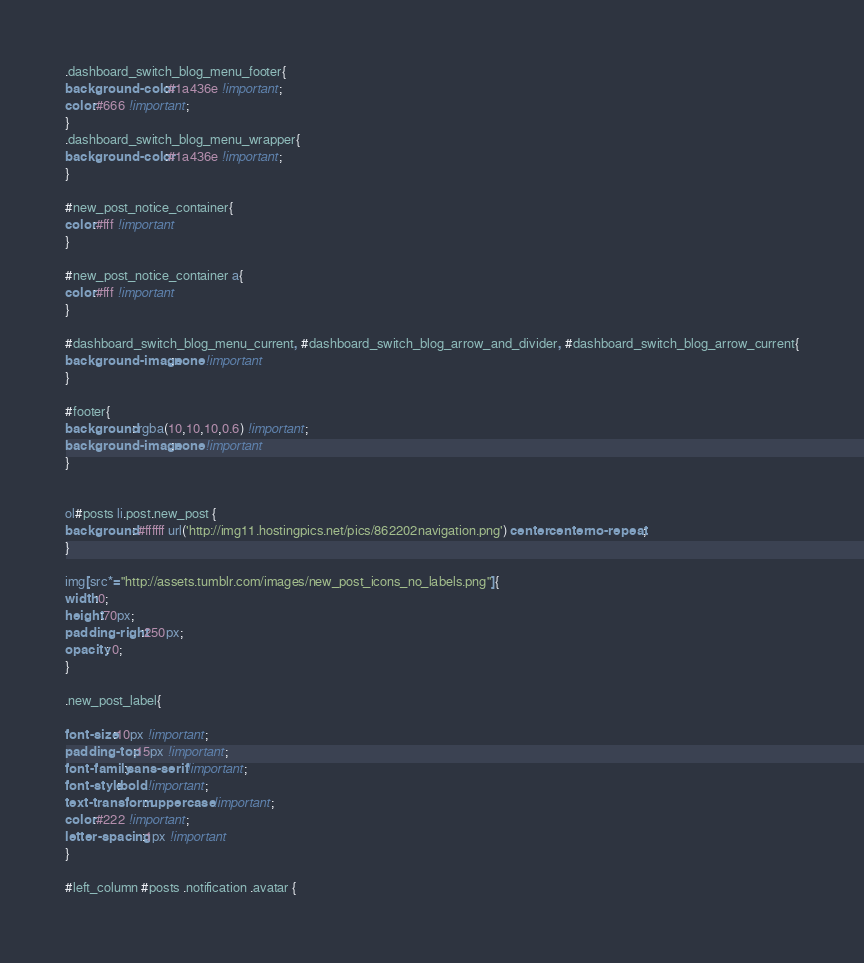Convert code to text. <code><loc_0><loc_0><loc_500><loc_500><_CSS_>
.dashboard_switch_blog_menu_footer{
background-color:#1a436e !important;
color:#666 !important;
}
.dashboard_switch_blog_menu_wrapper{
background-color:#1a436e !important;
}

#new_post_notice_container{
color:#fff !important
}

#new_post_notice_container a{
color:#fff !important
}

#dashboard_switch_blog_menu_current, #dashboard_switch_blog_arrow_and_divider, #dashboard_switch_blog_arrow_current{
background-image:none !important
}

#footer{
background: rgba(10,10,10,0.6) !important;
background-image:none !important
}


ol#posts li.post.new_post {
background: #ffffff url('http://img11.hostingpics.net/pics/862202navigation.png') center center no-repeat;
}

img[src*="http://assets.tumblr.com/images/new_post_icons_no_labels.png"]{
width:0;
height:70px;
padding-right:250px;
opacity: 0;
}

.new_post_label{

font-size:10px !important;
padding-top:15px !important;
font-family:sans-serif !important;
font-style:bold !important;
text-transform: uppercase !important;
color:#222 !important;
letter-spacing:1px !important
}

#left_column #posts .notification .avatar {</code> 